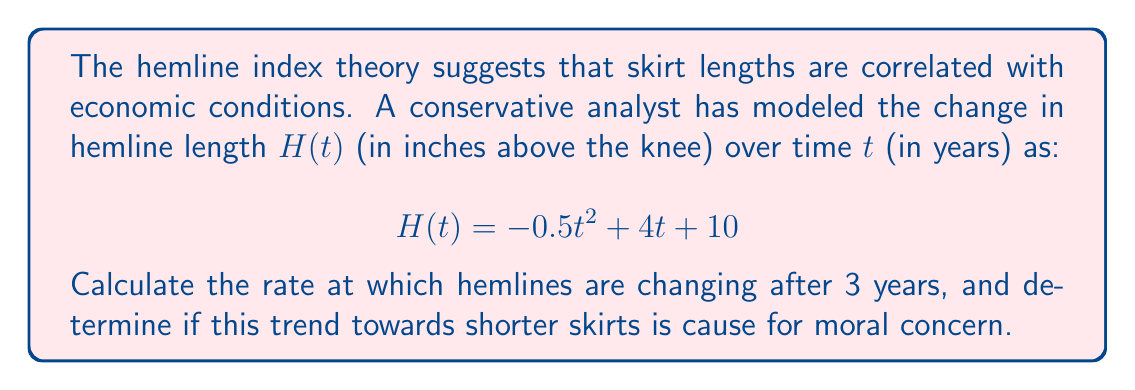Show me your answer to this math problem. To find the rate of change in hemline length after 3 years, we need to calculate the derivative of $H(t)$ and evaluate it at $t=3$.

Step 1: Find the derivative of $H(t)$
$$\frac{d}{dt}H(t) = \frac{d}{dt}(-0.5t^2 + 4t + 10)$$
$$H'(t) = -t + 4$$

Step 2: Evaluate $H'(t)$ at $t=3$
$$H'(3) = -3 + 4 = 1$$

The rate of change is 1 inch per year at $t=3$.

Step 3: Interpret the result
A positive rate of change indicates that hemlines are still rising (getting shorter) after 3 years, which may be concerning from a conservative perspective. However, the rate of increase is slowing down compared to the initial rate of 4 inches per year (when $t=0$).
Answer: $1$ inch per year 